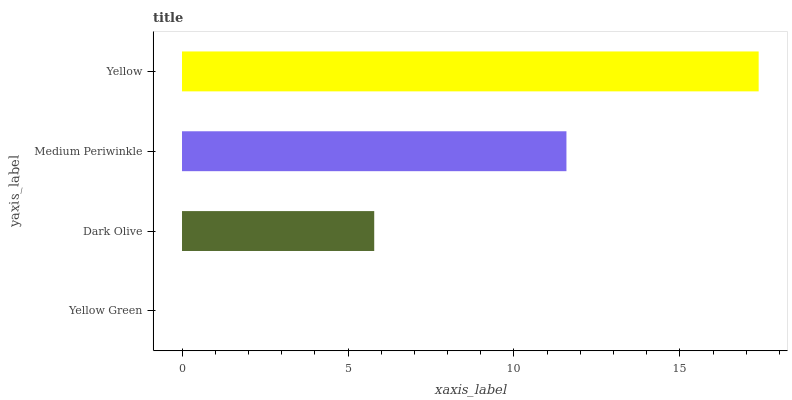Is Yellow Green the minimum?
Answer yes or no. Yes. Is Yellow the maximum?
Answer yes or no. Yes. Is Dark Olive the minimum?
Answer yes or no. No. Is Dark Olive the maximum?
Answer yes or no. No. Is Dark Olive greater than Yellow Green?
Answer yes or no. Yes. Is Yellow Green less than Dark Olive?
Answer yes or no. Yes. Is Yellow Green greater than Dark Olive?
Answer yes or no. No. Is Dark Olive less than Yellow Green?
Answer yes or no. No. Is Medium Periwinkle the high median?
Answer yes or no. Yes. Is Dark Olive the low median?
Answer yes or no. Yes. Is Yellow the high median?
Answer yes or no. No. Is Yellow Green the low median?
Answer yes or no. No. 